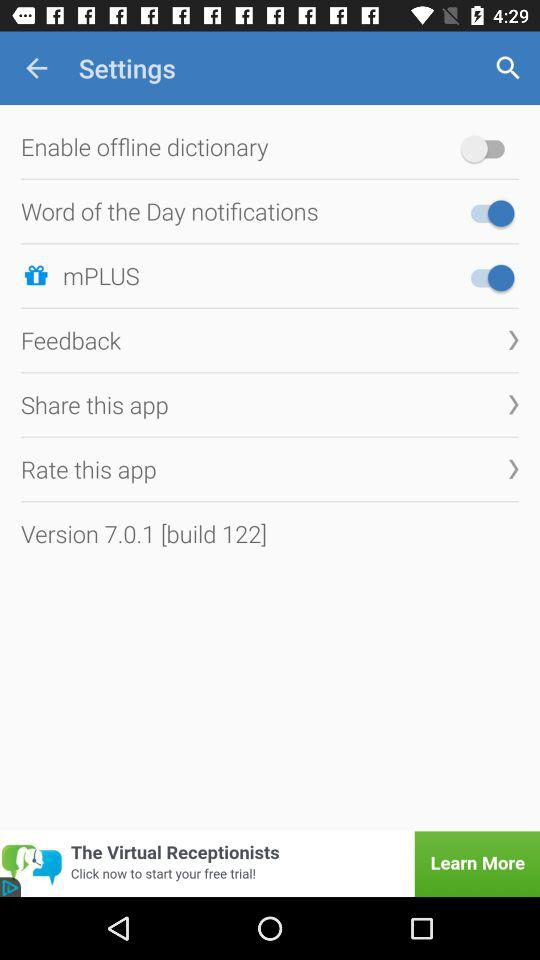What is the status of the "mPLUS" button? The status of the "mPLUS" button is "on". 